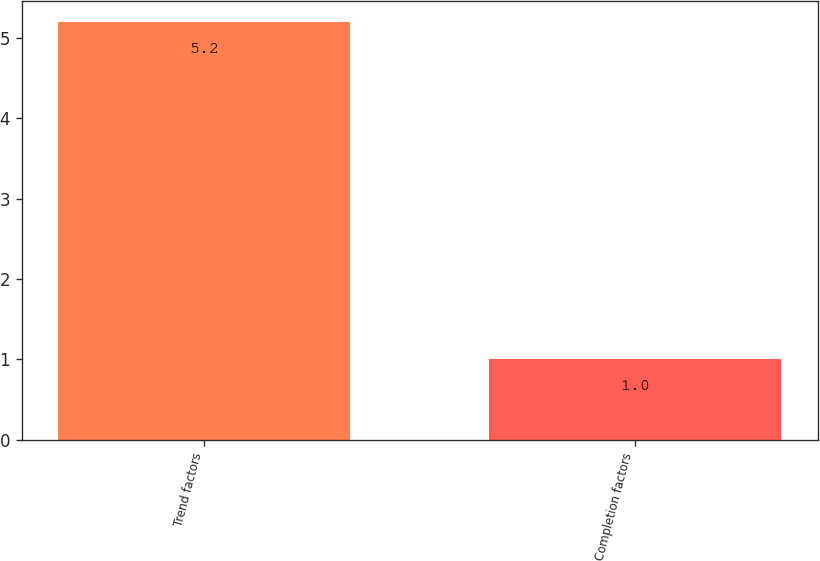<chart> <loc_0><loc_0><loc_500><loc_500><bar_chart><fcel>Trend factors<fcel>Completion factors<nl><fcel>5.2<fcel>1<nl></chart> 